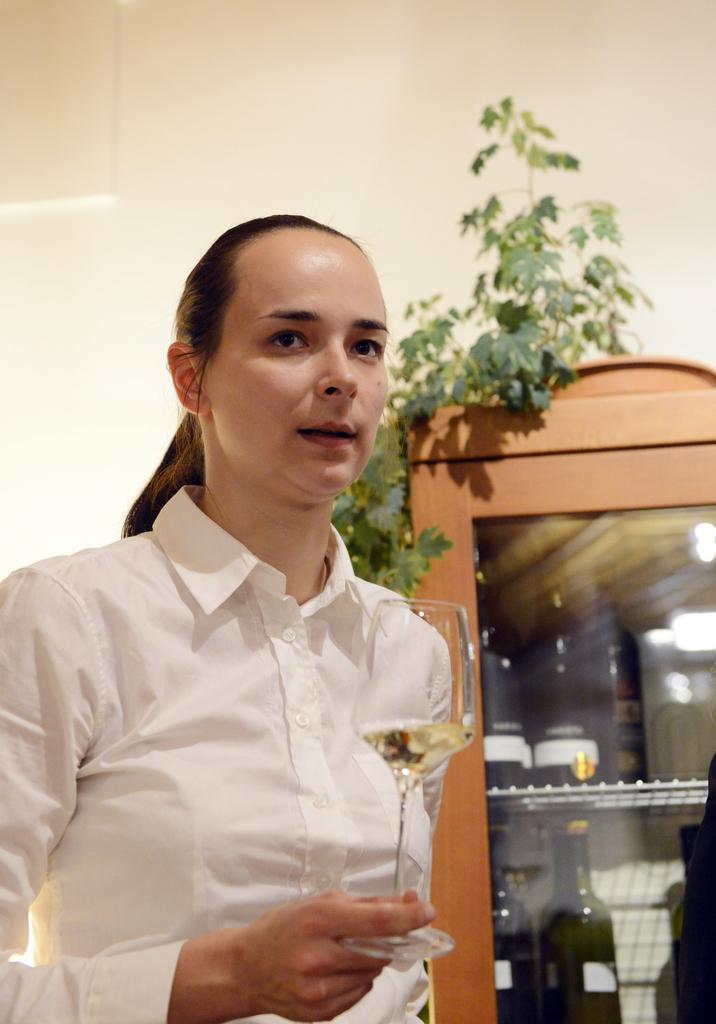In one or two sentences, can you explain what this image depicts? This is a picture of a lady who wore a white shirt and holding a glass in her right hand behind her there is a shelf in which there are some bottles and a plant above it. 